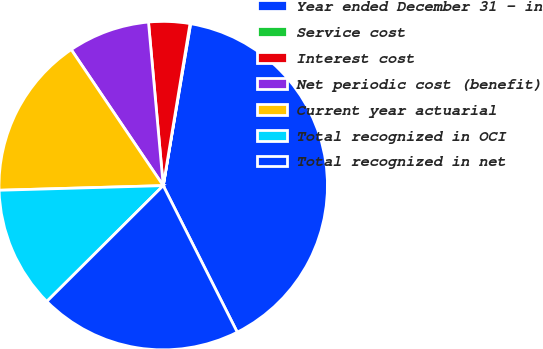<chart> <loc_0><loc_0><loc_500><loc_500><pie_chart><fcel>Year ended December 31 - in<fcel>Service cost<fcel>Interest cost<fcel>Net periodic cost (benefit)<fcel>Current year actuarial<fcel>Total recognized in OCI<fcel>Total recognized in net<nl><fcel>39.89%<fcel>0.06%<fcel>4.04%<fcel>8.03%<fcel>15.99%<fcel>12.01%<fcel>19.98%<nl></chart> 